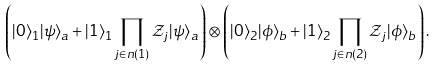<formula> <loc_0><loc_0><loc_500><loc_500>\left ( | 0 \rangle _ { 1 } | \psi \rangle _ { a } + | 1 \rangle _ { 1 } \prod _ { j \in n ( 1 ) } { \mathcal { Z } } _ { j } | \psi \rangle _ { a } \right ) \otimes \left ( | 0 \rangle _ { 2 } | \phi \rangle _ { b } + | 1 \rangle _ { 2 } \prod _ { j \in n ( 2 ) } { \mathcal { Z } } _ { j } | \phi \rangle _ { b } \right ) .</formula> 